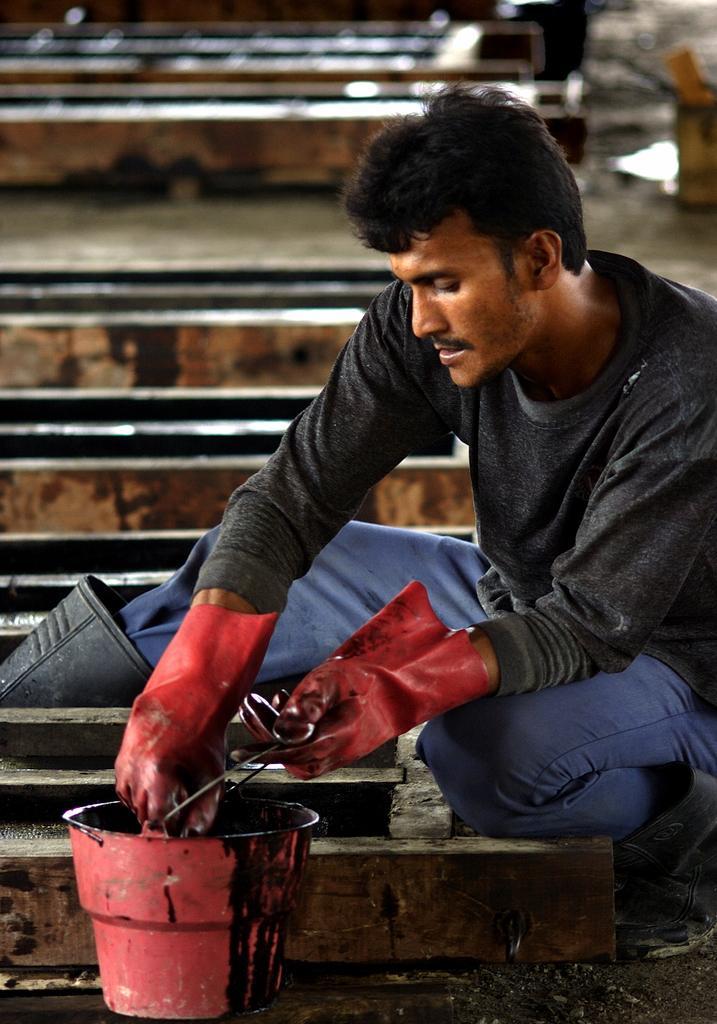How would you summarize this image in a sentence or two? As we can see in the image there are stairs. There is pot and on the right side there is a man wearing black color jacket. 